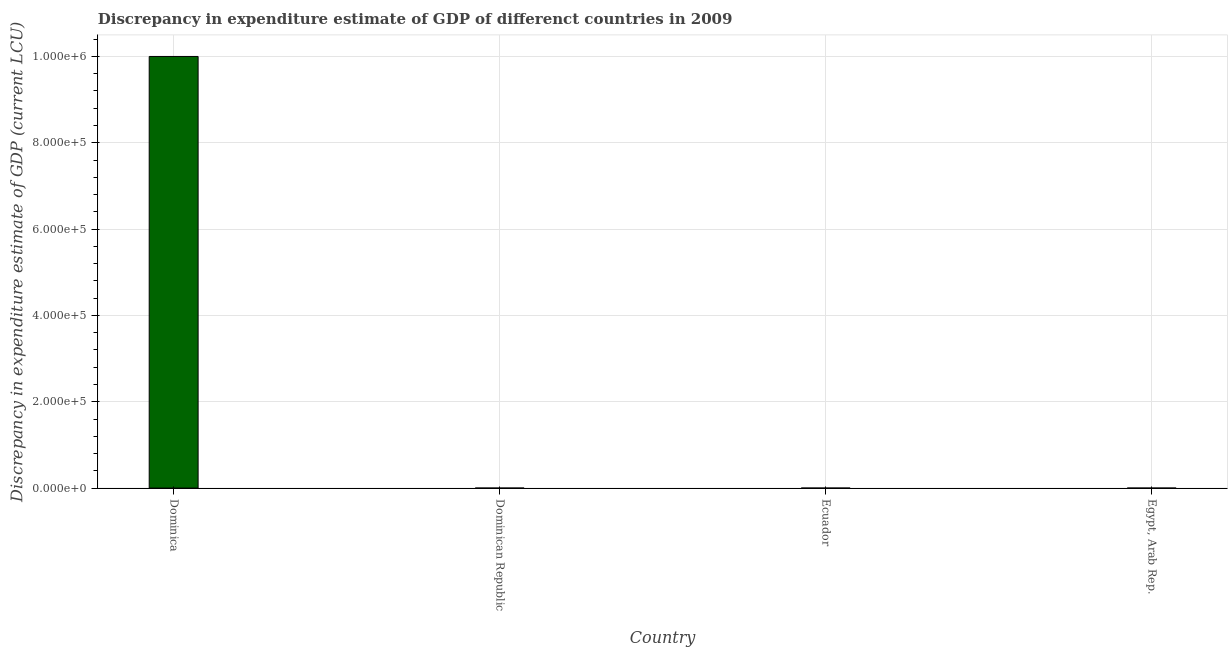Does the graph contain any zero values?
Offer a terse response. Yes. Does the graph contain grids?
Provide a succinct answer. Yes. What is the title of the graph?
Your answer should be compact. Discrepancy in expenditure estimate of GDP of differenct countries in 2009. What is the label or title of the Y-axis?
Give a very brief answer. Discrepancy in expenditure estimate of GDP (current LCU). What is the discrepancy in expenditure estimate of gdp in Ecuador?
Provide a short and direct response. 1e-6. Across all countries, what is the maximum discrepancy in expenditure estimate of gdp?
Offer a terse response. 1.00e+06. Across all countries, what is the minimum discrepancy in expenditure estimate of gdp?
Ensure brevity in your answer.  0. In which country was the discrepancy in expenditure estimate of gdp maximum?
Ensure brevity in your answer.  Dominica. What is the sum of the discrepancy in expenditure estimate of gdp?
Your answer should be compact. 1.00e+06. What is the average discrepancy in expenditure estimate of gdp per country?
Your response must be concise. 2.50e+05. What is the median discrepancy in expenditure estimate of gdp?
Your answer should be compact. 1.55e-5. In how many countries, is the discrepancy in expenditure estimate of gdp greater than 200000 LCU?
Offer a very short reply. 1. What is the ratio of the discrepancy in expenditure estimate of gdp in Dominica to that in Ecuador?
Give a very brief answer. 1.00e+12. Is the discrepancy in expenditure estimate of gdp in Ecuador less than that in Egypt, Arab Rep.?
Give a very brief answer. Yes. Are all the bars in the graph horizontal?
Your answer should be compact. No. What is the difference between two consecutive major ticks on the Y-axis?
Your answer should be very brief. 2.00e+05. What is the Discrepancy in expenditure estimate of GDP (current LCU) of Dominica?
Your answer should be compact. 1.00e+06. What is the Discrepancy in expenditure estimate of GDP (current LCU) of Dominican Republic?
Ensure brevity in your answer.  0. What is the Discrepancy in expenditure estimate of GDP (current LCU) in Ecuador?
Keep it short and to the point. 1e-6. What is the Discrepancy in expenditure estimate of GDP (current LCU) in Egypt, Arab Rep.?
Your answer should be very brief. 3e-5. What is the difference between the Discrepancy in expenditure estimate of GDP (current LCU) in Dominica and Egypt, Arab Rep.?
Ensure brevity in your answer.  1.00e+06. What is the difference between the Discrepancy in expenditure estimate of GDP (current LCU) in Ecuador and Egypt, Arab Rep.?
Keep it short and to the point. -3e-5. What is the ratio of the Discrepancy in expenditure estimate of GDP (current LCU) in Dominica to that in Ecuador?
Provide a short and direct response. 1.00e+12. What is the ratio of the Discrepancy in expenditure estimate of GDP (current LCU) in Dominica to that in Egypt, Arab Rep.?
Provide a succinct answer. 3.33e+1. What is the ratio of the Discrepancy in expenditure estimate of GDP (current LCU) in Ecuador to that in Egypt, Arab Rep.?
Provide a succinct answer. 0.03. 